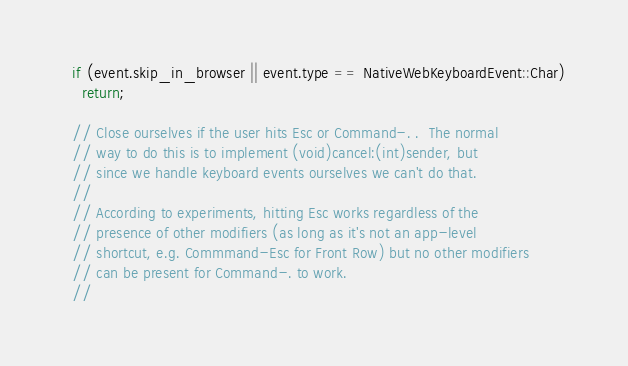<code> <loc_0><loc_0><loc_500><loc_500><_ObjectiveC_>  if (event.skip_in_browser || event.type == NativeWebKeyboardEvent::Char)
    return;

  // Close ourselves if the user hits Esc or Command-. .  The normal
  // way to do this is to implement (void)cancel:(int)sender, but
  // since we handle keyboard events ourselves we can't do that.
  //
  // According to experiments, hitting Esc works regardless of the
  // presence of other modifiers (as long as it's not an app-level
  // shortcut, e.g. Commmand-Esc for Front Row) but no other modifiers
  // can be present for Command-. to work.
  //</code> 